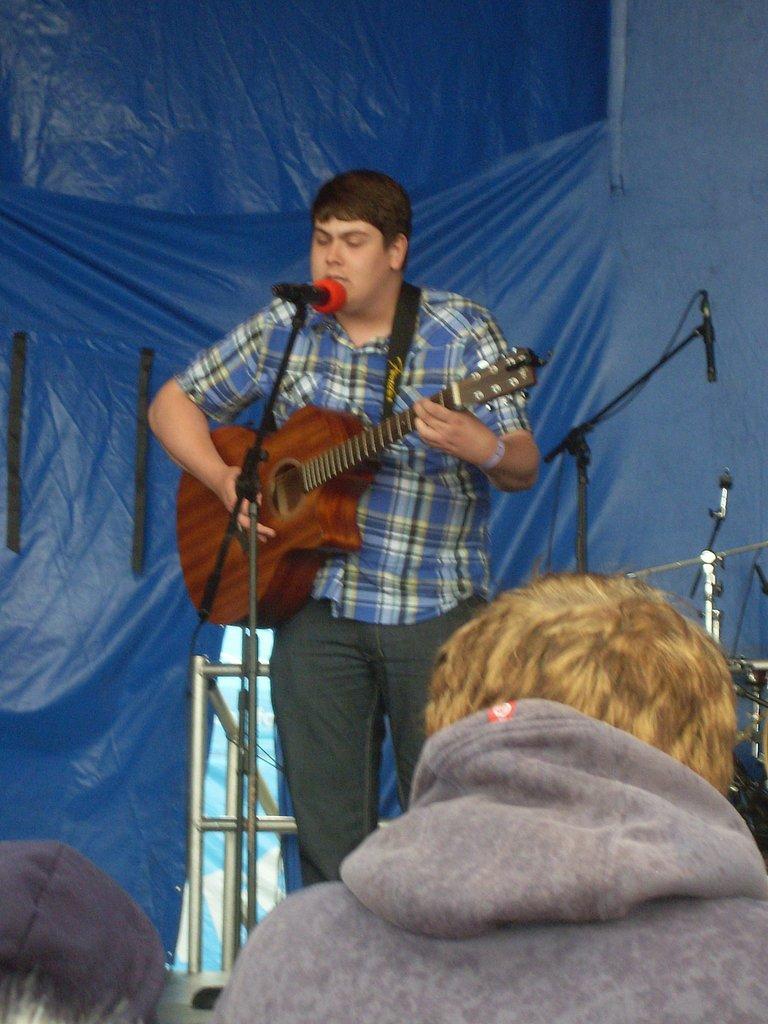Please provide a concise description of this image. A man is singing on mic and playing guitar. Behind him there is a banner,mic's,poles. In front of him there is a person. 